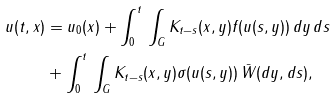Convert formula to latex. <formula><loc_0><loc_0><loc_500><loc_500>u ( t , x ) & = u _ { 0 } ( x ) + \int _ { 0 } ^ { t } \, \int _ { G } K _ { t - s } ( x , y ) f ( u ( s , y ) ) \, d y \, d s \\ & + \int _ { 0 } ^ { t } \, \int _ { G } K _ { t - s } ( x , y ) \sigma ( u ( s , y ) ) \, \bar { W } ( d y , d s ) ,</formula> 